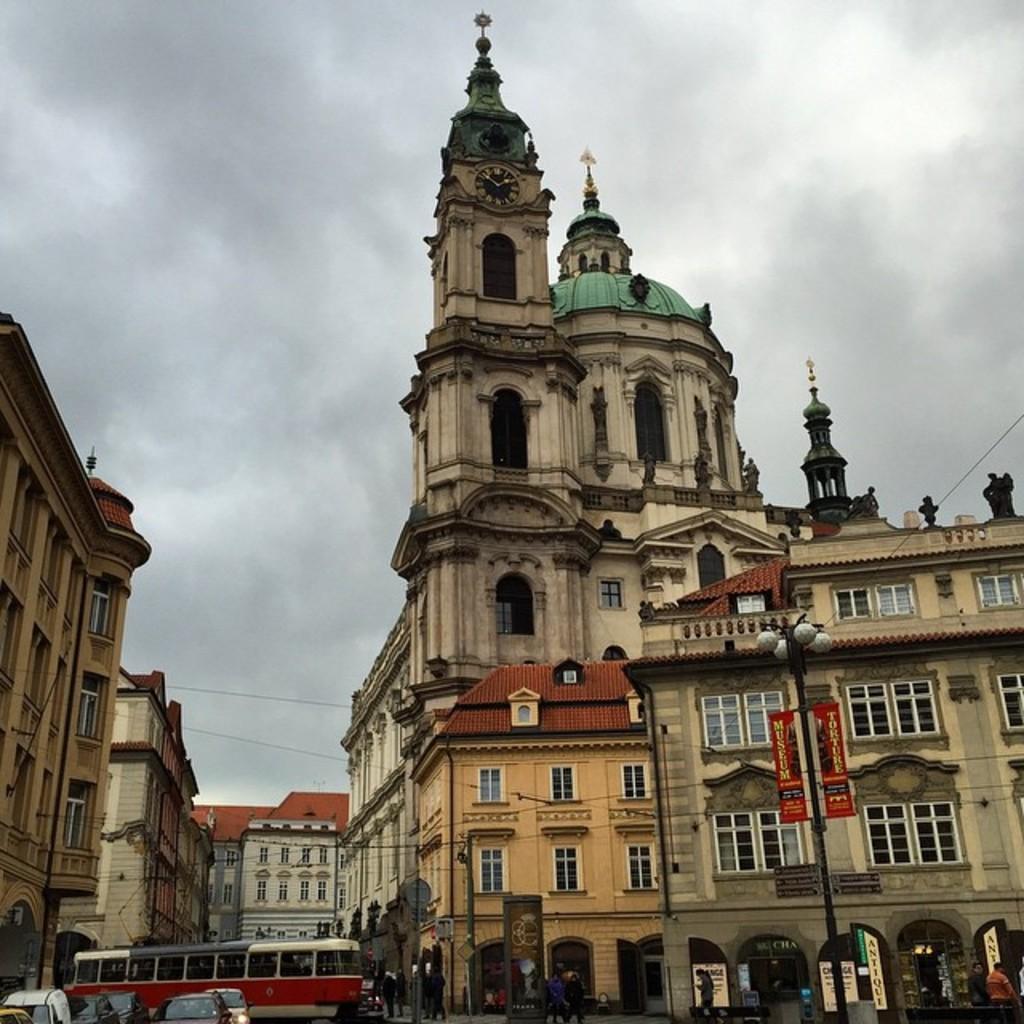Please provide a concise description of this image. In this image there are vehicles on a road and people walking on a footpath and there are poles, buildings and the sky. 